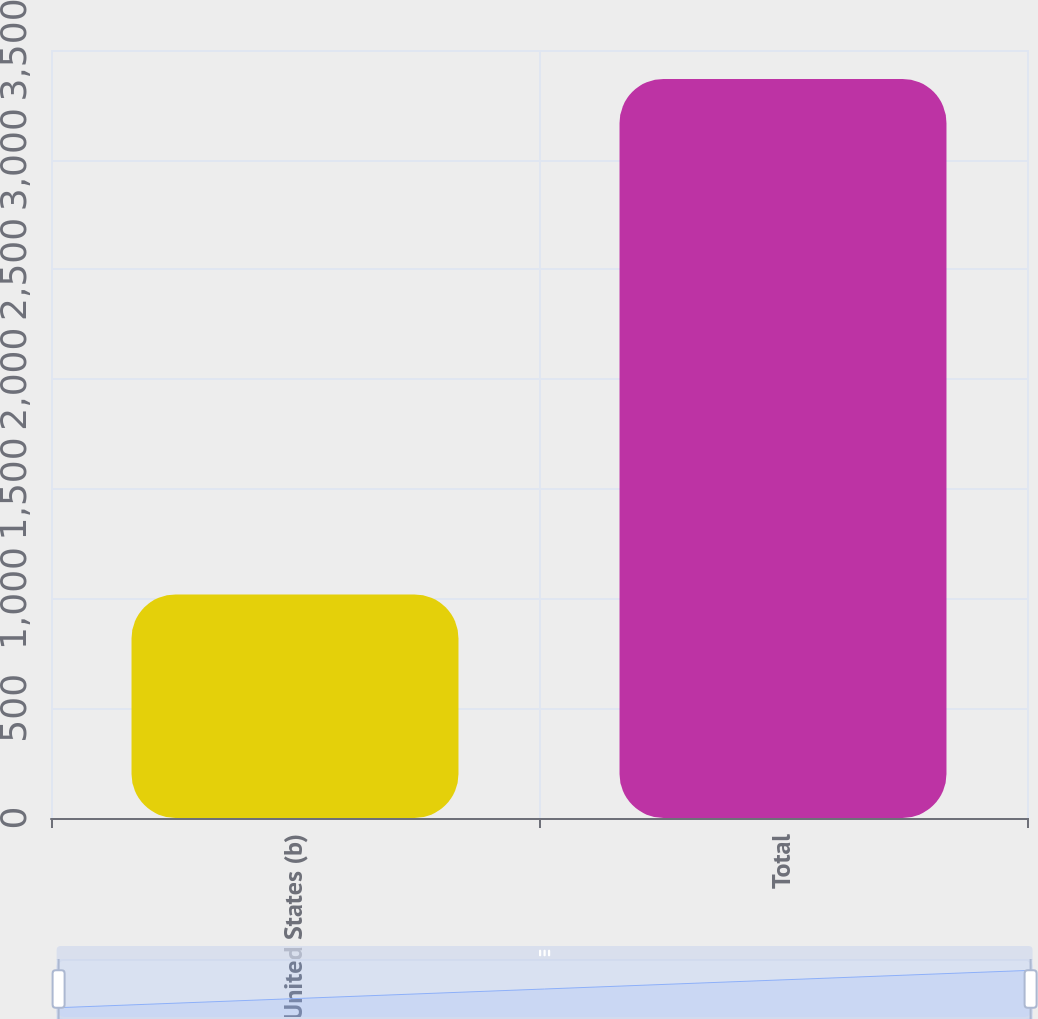<chart> <loc_0><loc_0><loc_500><loc_500><bar_chart><fcel>United States (b)<fcel>Total<nl><fcel>1019<fcel>3368<nl></chart> 